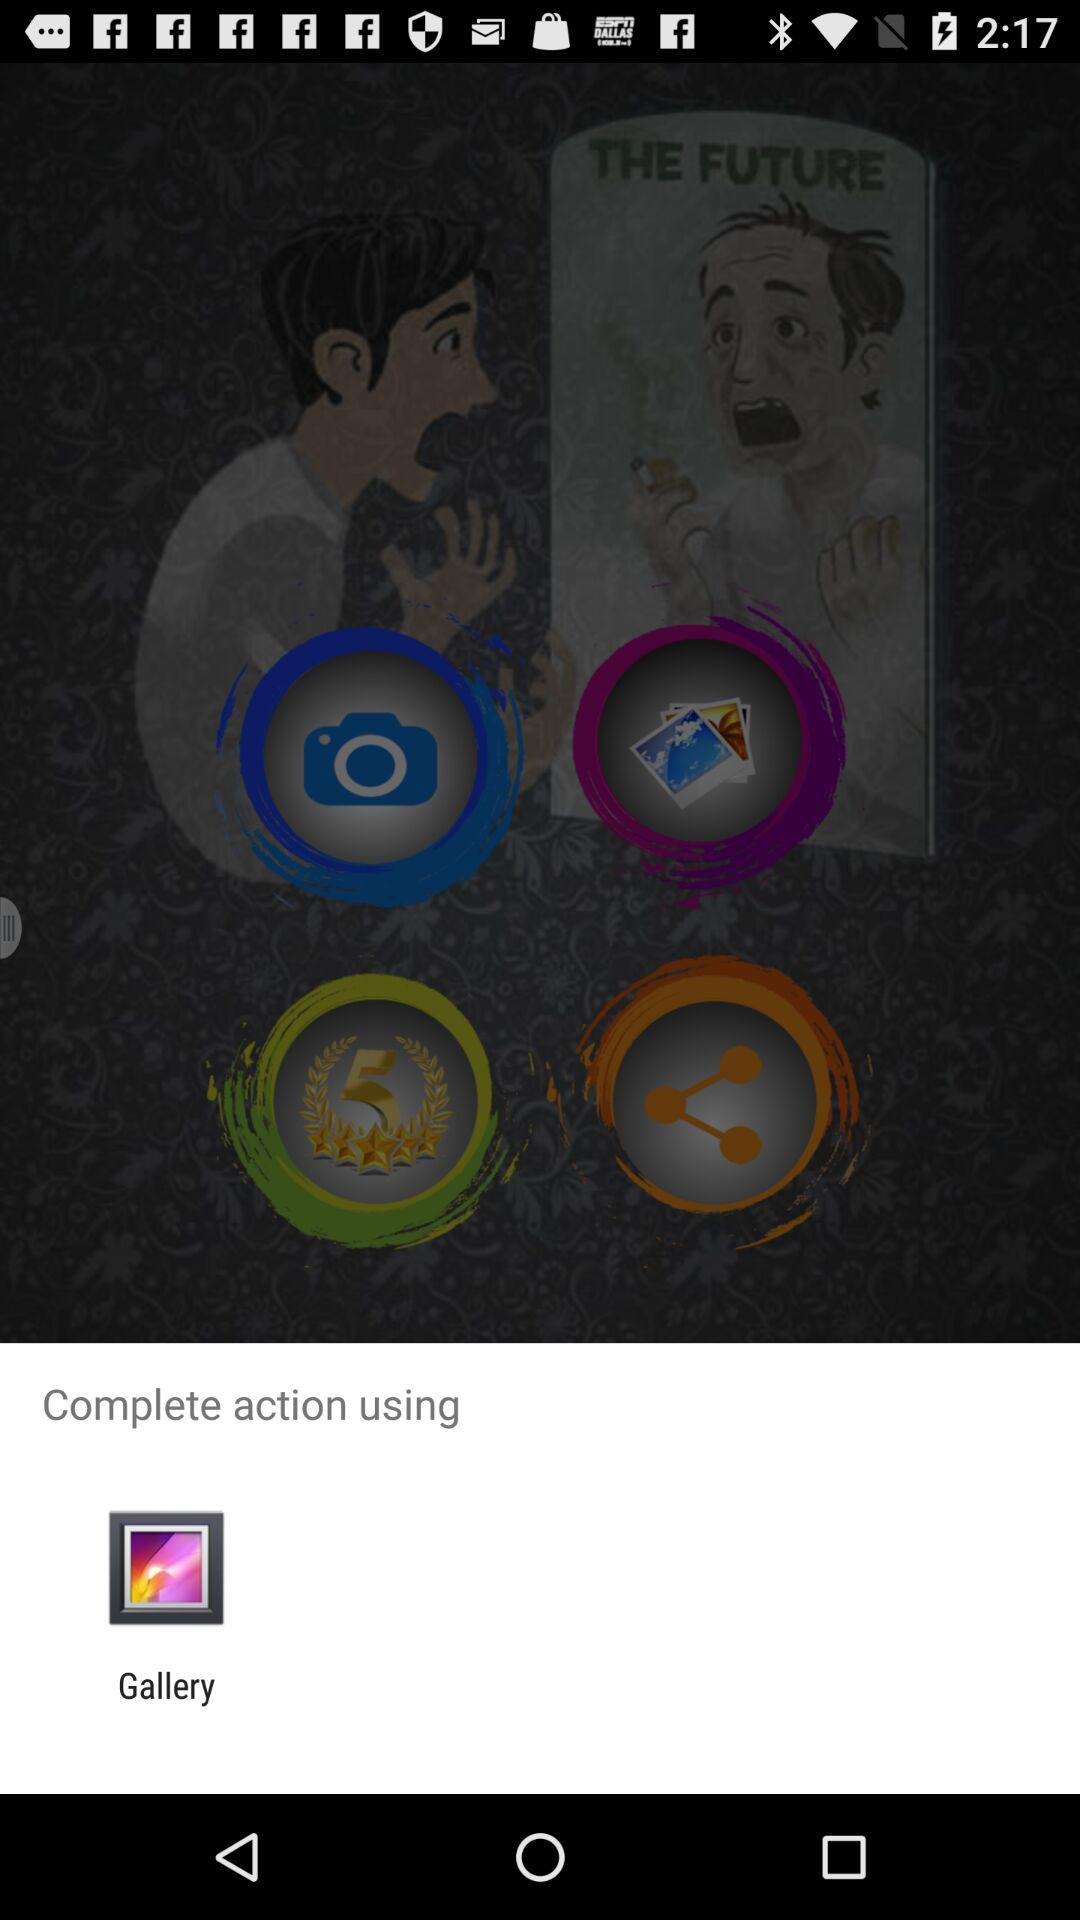What is the name of the application?
When the provided information is insufficient, respond with <no answer>. <no answer> 